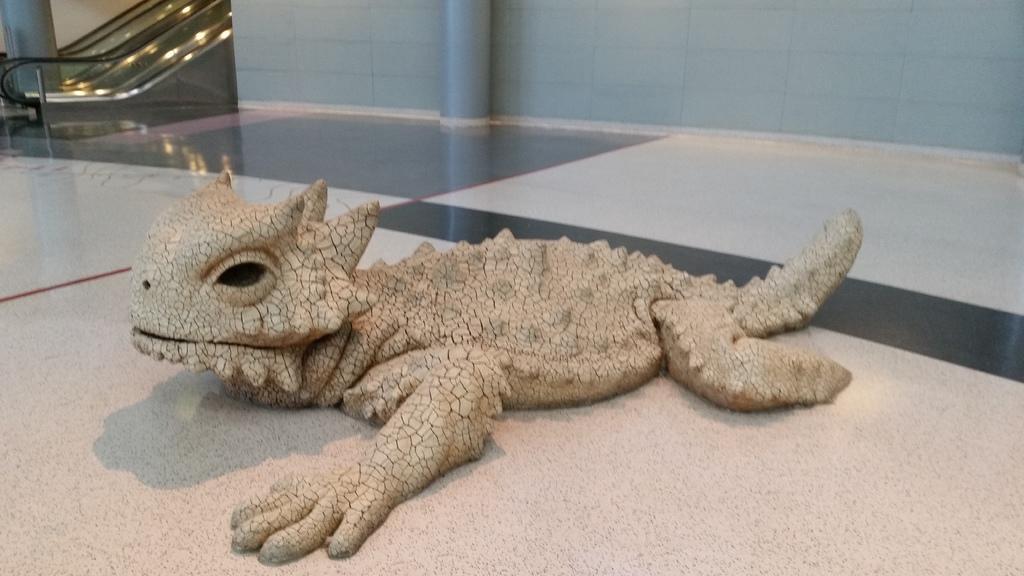Could you give a brief overview of what you see in this image? In this image we can see a toy reptile on the surface. On the backside we can see a wall, pillar and an escalator. 